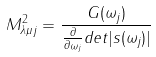<formula> <loc_0><loc_0><loc_500><loc_500>M _ { \lambda \mu j } ^ { 2 } = \frac { G ( \omega _ { j } ) } { \frac { \partial } { \partial \omega _ { j } } d e t | s ( \omega _ { j } ) | }</formula> 